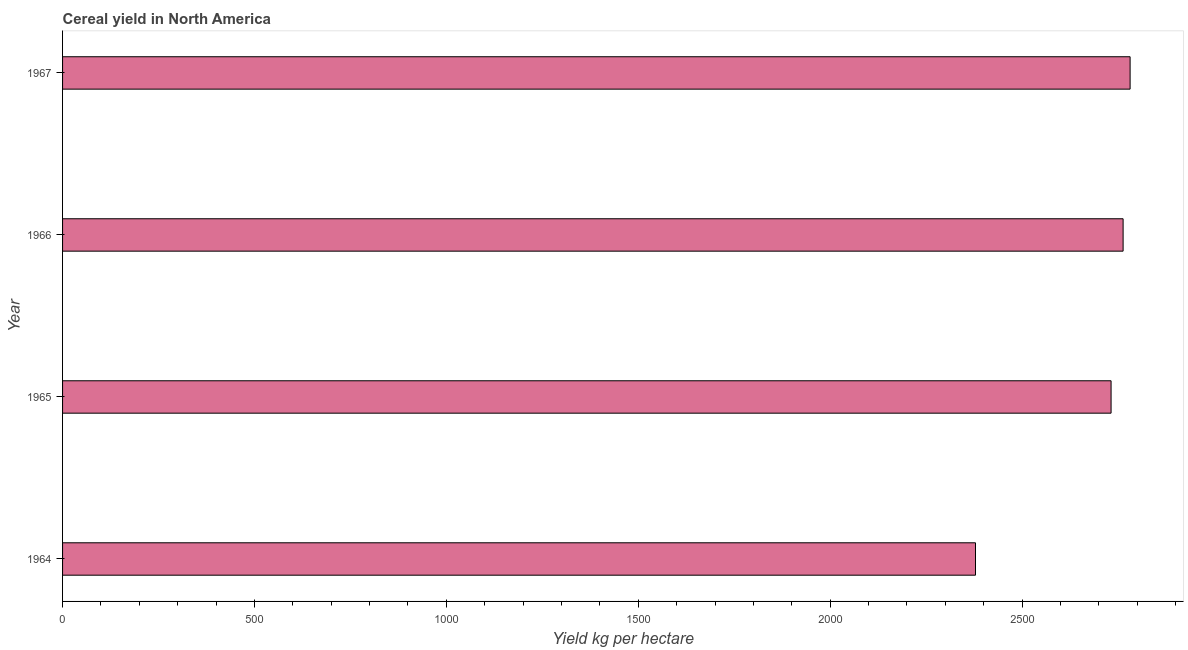Does the graph contain any zero values?
Provide a short and direct response. No. What is the title of the graph?
Your answer should be very brief. Cereal yield in North America. What is the label or title of the X-axis?
Give a very brief answer. Yield kg per hectare. What is the cereal yield in 1967?
Ensure brevity in your answer.  2781.51. Across all years, what is the maximum cereal yield?
Provide a succinct answer. 2781.51. Across all years, what is the minimum cereal yield?
Give a very brief answer. 2378.67. In which year was the cereal yield maximum?
Offer a terse response. 1967. In which year was the cereal yield minimum?
Provide a succinct answer. 1964. What is the sum of the cereal yield?
Make the answer very short. 1.07e+04. What is the difference between the cereal yield in 1964 and 1967?
Give a very brief answer. -402.84. What is the average cereal yield per year?
Ensure brevity in your answer.  2663.83. What is the median cereal yield?
Offer a terse response. 2747.57. In how many years, is the cereal yield greater than 600 kg per hectare?
Provide a short and direct response. 4. Do a majority of the years between 1965 and 1967 (inclusive) have cereal yield greater than 900 kg per hectare?
Your answer should be compact. Yes. What is the ratio of the cereal yield in 1964 to that in 1966?
Keep it short and to the point. 0.86. What is the difference between the highest and the second highest cereal yield?
Your answer should be compact. 18.26. Is the sum of the cereal yield in 1965 and 1966 greater than the maximum cereal yield across all years?
Ensure brevity in your answer.  Yes. What is the difference between the highest and the lowest cereal yield?
Offer a very short reply. 402.84. In how many years, is the cereal yield greater than the average cereal yield taken over all years?
Provide a short and direct response. 3. Are all the bars in the graph horizontal?
Your response must be concise. Yes. How many years are there in the graph?
Give a very brief answer. 4. What is the Yield kg per hectare in 1964?
Keep it short and to the point. 2378.67. What is the Yield kg per hectare in 1965?
Your answer should be compact. 2731.89. What is the Yield kg per hectare in 1966?
Provide a succinct answer. 2763.25. What is the Yield kg per hectare of 1967?
Your answer should be compact. 2781.51. What is the difference between the Yield kg per hectare in 1964 and 1965?
Your answer should be compact. -353.22. What is the difference between the Yield kg per hectare in 1964 and 1966?
Offer a very short reply. -384.58. What is the difference between the Yield kg per hectare in 1964 and 1967?
Give a very brief answer. -402.84. What is the difference between the Yield kg per hectare in 1965 and 1966?
Keep it short and to the point. -31.36. What is the difference between the Yield kg per hectare in 1965 and 1967?
Provide a short and direct response. -49.62. What is the difference between the Yield kg per hectare in 1966 and 1967?
Your response must be concise. -18.26. What is the ratio of the Yield kg per hectare in 1964 to that in 1965?
Give a very brief answer. 0.87. What is the ratio of the Yield kg per hectare in 1964 to that in 1966?
Make the answer very short. 0.86. What is the ratio of the Yield kg per hectare in 1964 to that in 1967?
Your response must be concise. 0.85. What is the ratio of the Yield kg per hectare in 1965 to that in 1966?
Provide a succinct answer. 0.99. What is the ratio of the Yield kg per hectare in 1965 to that in 1967?
Offer a very short reply. 0.98. 